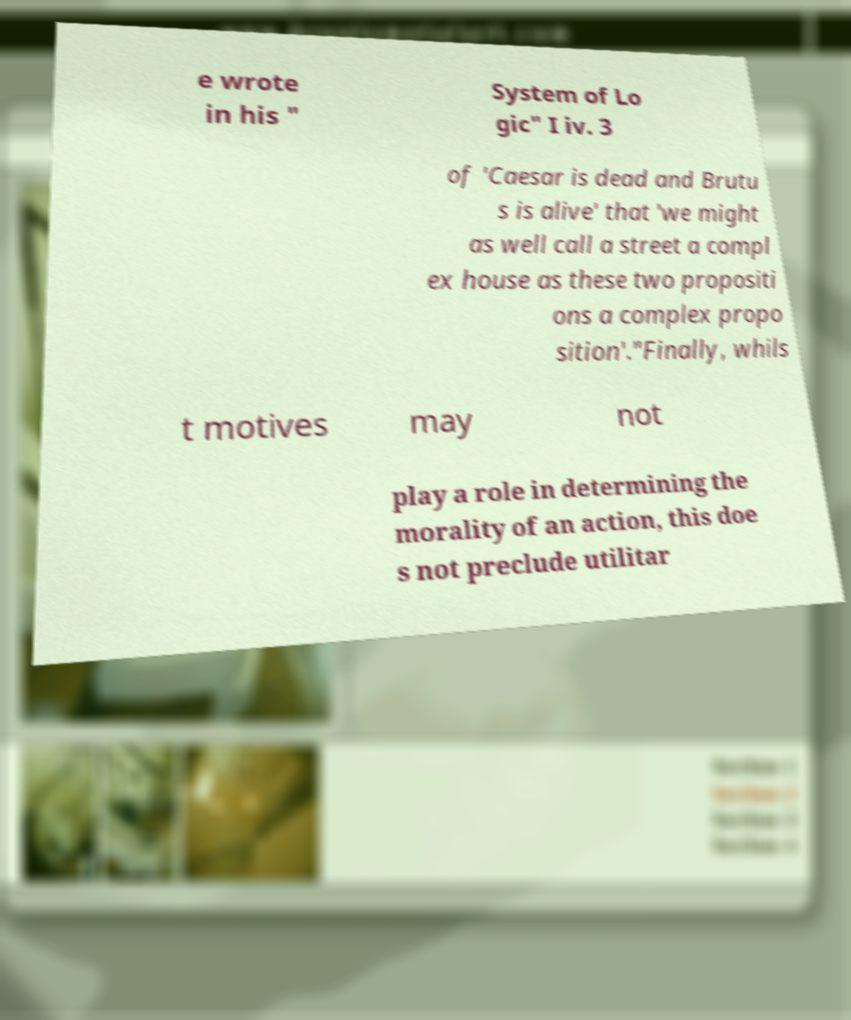Could you assist in decoding the text presented in this image and type it out clearly? e wrote in his " System of Lo gic" I iv. 3 of 'Caesar is dead and Brutu s is alive' that 'we might as well call a street a compl ex house as these two propositi ons a complex propo sition'."Finally, whils t motives may not play a role in determining the morality of an action, this doe s not preclude utilitar 